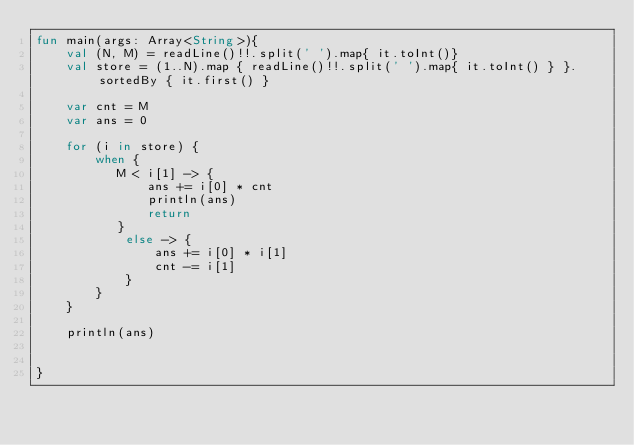<code> <loc_0><loc_0><loc_500><loc_500><_Kotlin_>fun main(args: Array<String>){
    val (N, M) = readLine()!!.split(' ').map{ it.toInt()}
    val store = (1..N).map { readLine()!!.split(' ').map{ it.toInt() } }.sortedBy { it.first() }

    var cnt = M
    var ans = 0

    for (i in store) {
        when {
           M < i[1] -> {
               ans += i[0] * cnt
               println(ans)
               return
           }
            else -> {
                ans += i[0] * i[1]
                cnt -= i[1]
            }
        }
    }

    println(ans)


}</code> 